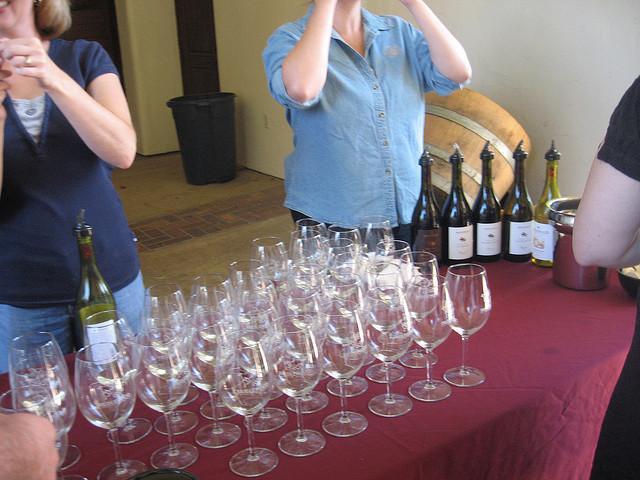How many people are in the picture?
Give a very brief answer. 4. How many bottles are in the photo?
Give a very brief answer. 4. How many wine glasses can be seen?
Give a very brief answer. 11. 